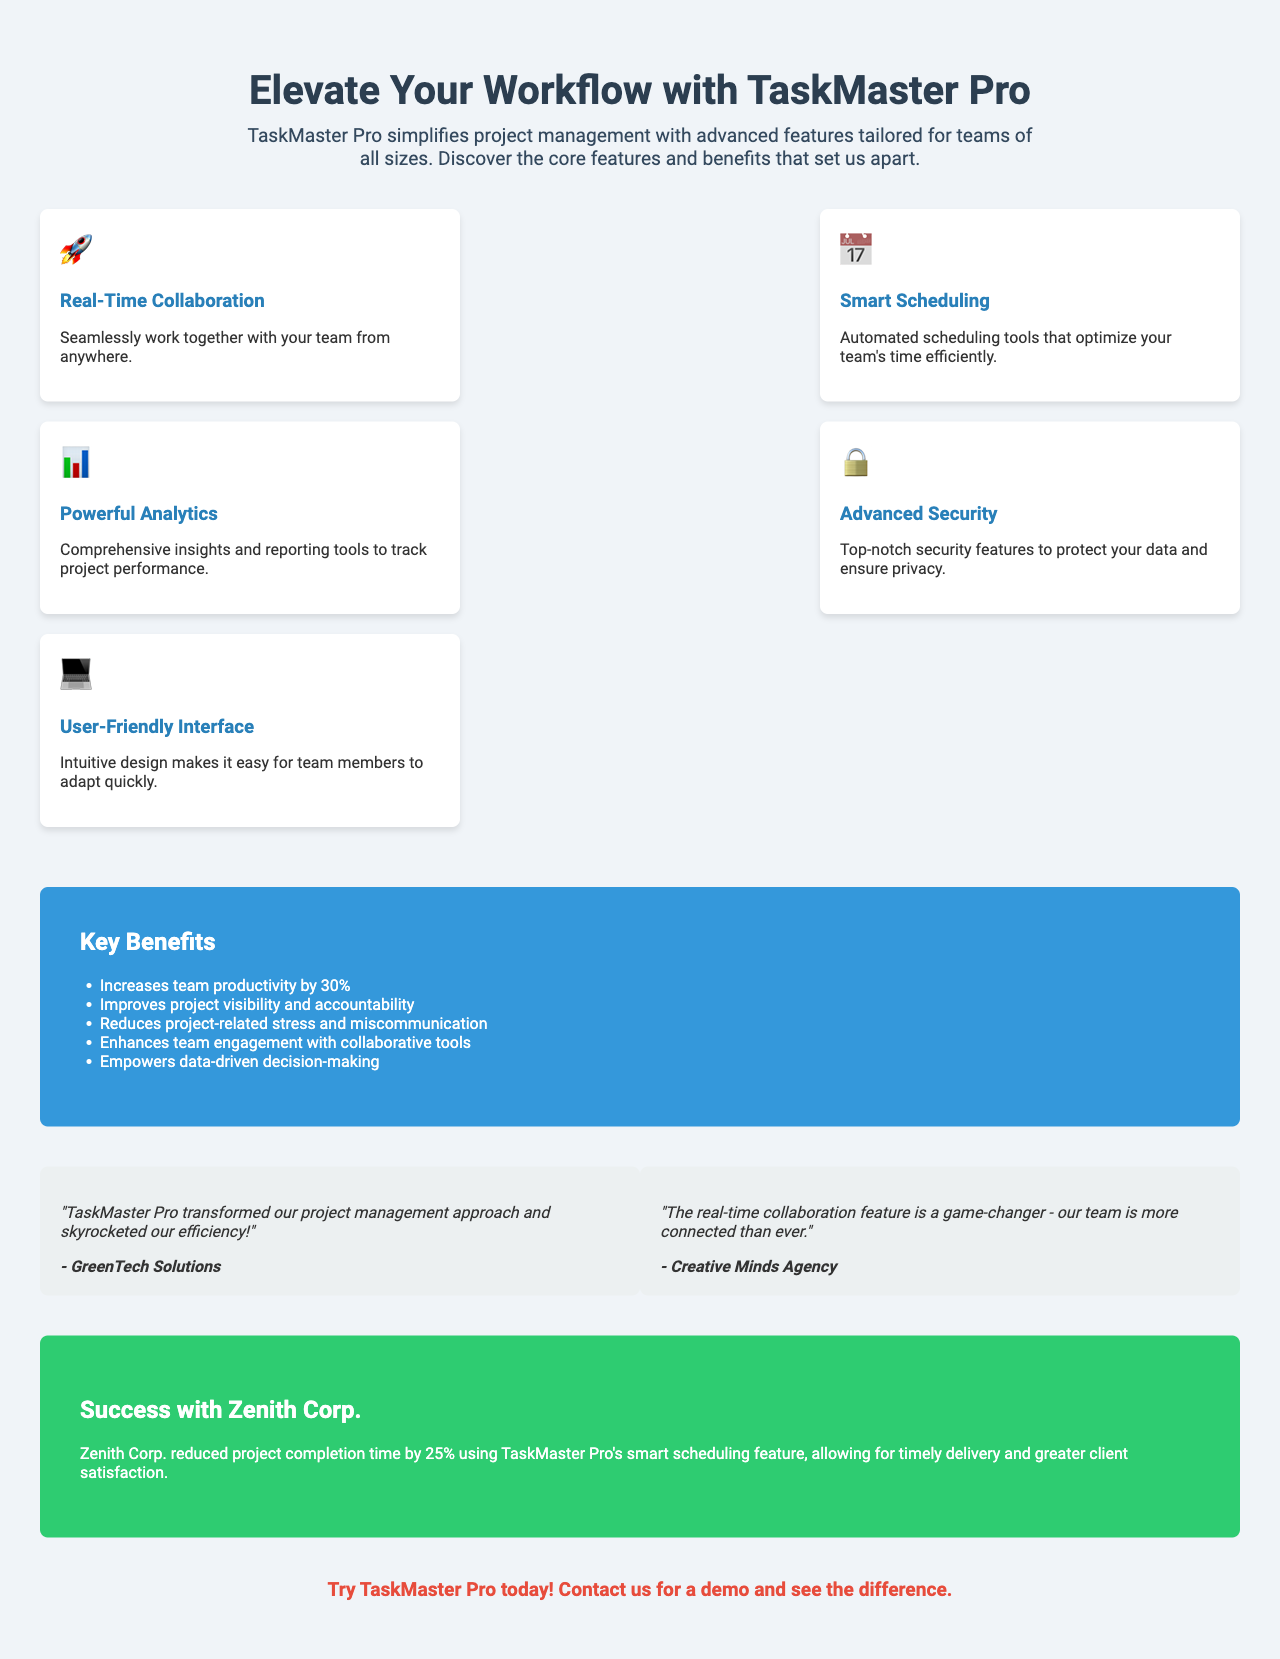What is the title of the brochure? The title is prominently displayed in the header of the brochure.
Answer: Elevate Your Workflow with TaskMaster Pro How many core features are highlighted in the brochure? The brochure lists five core features in the section labeled "features."
Answer: Five What is the icon used for "User-Friendly Interface"? Each feature has a unique icon, which represents its functionality visually.
Answer: 💻 What is one key benefit of using TaskMaster Pro? The benefits section lists several advantages; one example illustrates productivity enhancement.
Answer: Increases team productivity by 30% Which company provided a testimonial about efficiency? The testimonials section features quotes from two companies, showcasing positive feedback.
Answer: GreenTech Solutions What was achieved by Zenith Corp. using TaskMaster Pro? The case study details specific improvements observed by a user company through TaskMaster Pro.
Answer: Reduced project completion time by 25% What color is the "Key Benefits" section? The design of the brochure utilizes color coding to differentiate sections.
Answer: Blue What is a unique feature of TaskMaster Pro that enhances collaboration? The features section indicates a particular benefit of using the product focused on team interaction.
Answer: Real-Time Collaboration Which section contains a call to action? The brochure concludes with a section that encourages readers to take action regarding the product.
Answer: Yes, it is in the "cta" section 